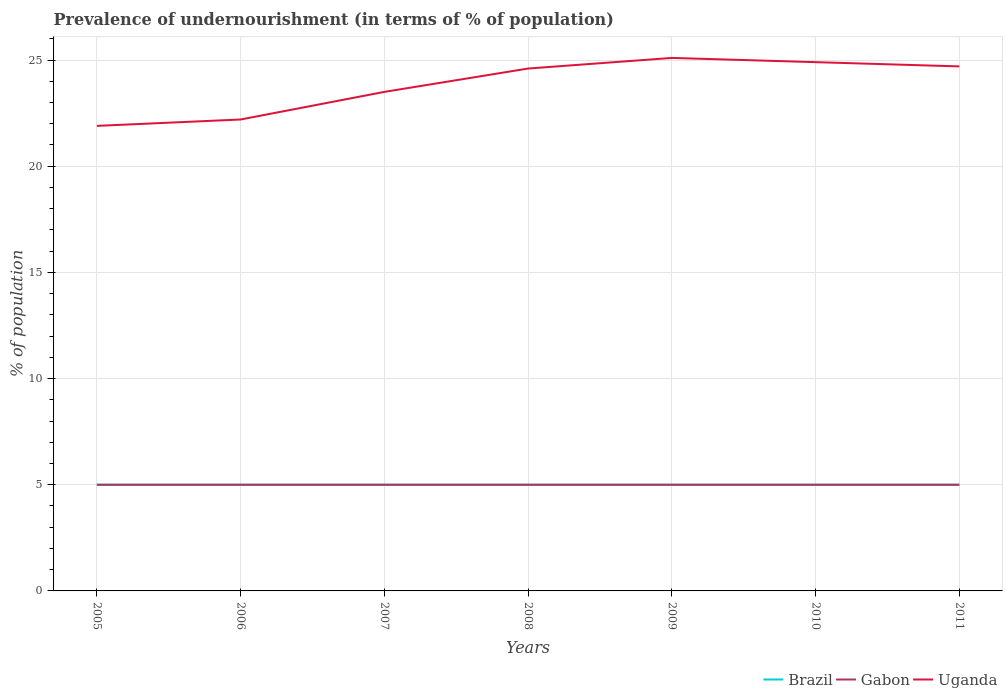Across all years, what is the maximum percentage of undernourished population in Uganda?
Make the answer very short. 21.9. What is the difference between the highest and the lowest percentage of undernourished population in Brazil?
Ensure brevity in your answer.  0. How many lines are there?
Your answer should be very brief. 3. How many years are there in the graph?
Provide a succinct answer. 7. What is the difference between two consecutive major ticks on the Y-axis?
Ensure brevity in your answer.  5. Does the graph contain any zero values?
Provide a succinct answer. No. Where does the legend appear in the graph?
Provide a succinct answer. Bottom right. What is the title of the graph?
Your answer should be very brief. Prevalence of undernourishment (in terms of % of population). What is the label or title of the X-axis?
Provide a short and direct response. Years. What is the label or title of the Y-axis?
Your answer should be very brief. % of population. What is the % of population of Brazil in 2005?
Provide a succinct answer. 5. What is the % of population of Uganda in 2005?
Your response must be concise. 21.9. What is the % of population of Brazil in 2006?
Offer a very short reply. 5. What is the % of population of Gabon in 2006?
Offer a terse response. 5. What is the % of population in Uganda in 2006?
Keep it short and to the point. 22.2. What is the % of population of Brazil in 2007?
Offer a very short reply. 5. What is the % of population of Gabon in 2007?
Offer a terse response. 5. What is the % of population in Gabon in 2008?
Your answer should be very brief. 5. What is the % of population in Uganda in 2008?
Make the answer very short. 24.6. What is the % of population of Gabon in 2009?
Keep it short and to the point. 5. What is the % of population of Uganda in 2009?
Make the answer very short. 25.1. What is the % of population in Uganda in 2010?
Your response must be concise. 24.9. What is the % of population of Brazil in 2011?
Your answer should be very brief. 5. What is the % of population of Gabon in 2011?
Offer a terse response. 5. What is the % of population of Uganda in 2011?
Give a very brief answer. 24.7. Across all years, what is the maximum % of population of Uganda?
Offer a very short reply. 25.1. Across all years, what is the minimum % of population in Uganda?
Keep it short and to the point. 21.9. What is the total % of population in Brazil in the graph?
Your answer should be very brief. 35. What is the total % of population in Gabon in the graph?
Your answer should be very brief. 35. What is the total % of population of Uganda in the graph?
Offer a very short reply. 166.9. What is the difference between the % of population of Gabon in 2005 and that in 2006?
Your response must be concise. 0. What is the difference between the % of population of Uganda in 2005 and that in 2006?
Your answer should be very brief. -0.3. What is the difference between the % of population of Brazil in 2005 and that in 2007?
Give a very brief answer. 0. What is the difference between the % of population of Brazil in 2005 and that in 2009?
Keep it short and to the point. 0. What is the difference between the % of population in Gabon in 2005 and that in 2009?
Offer a very short reply. 0. What is the difference between the % of population in Uganda in 2005 and that in 2010?
Offer a terse response. -3. What is the difference between the % of population in Brazil in 2005 and that in 2011?
Offer a very short reply. 0. What is the difference between the % of population in Gabon in 2005 and that in 2011?
Ensure brevity in your answer.  0. What is the difference between the % of population of Brazil in 2006 and that in 2007?
Keep it short and to the point. 0. What is the difference between the % of population in Gabon in 2006 and that in 2007?
Ensure brevity in your answer.  0. What is the difference between the % of population in Uganda in 2006 and that in 2007?
Provide a short and direct response. -1.3. What is the difference between the % of population of Gabon in 2006 and that in 2008?
Your answer should be very brief. 0. What is the difference between the % of population in Uganda in 2006 and that in 2008?
Your answer should be compact. -2.4. What is the difference between the % of population in Brazil in 2006 and that in 2011?
Your answer should be very brief. 0. What is the difference between the % of population of Gabon in 2006 and that in 2011?
Offer a very short reply. 0. What is the difference between the % of population of Uganda in 2007 and that in 2008?
Provide a short and direct response. -1.1. What is the difference between the % of population of Uganda in 2007 and that in 2009?
Your response must be concise. -1.6. What is the difference between the % of population of Brazil in 2007 and that in 2010?
Offer a very short reply. 0. What is the difference between the % of population in Gabon in 2007 and that in 2011?
Keep it short and to the point. 0. What is the difference between the % of population of Uganda in 2007 and that in 2011?
Provide a short and direct response. -1.2. What is the difference between the % of population in Brazil in 2008 and that in 2009?
Give a very brief answer. 0. What is the difference between the % of population in Uganda in 2008 and that in 2009?
Offer a terse response. -0.5. What is the difference between the % of population of Brazil in 2008 and that in 2010?
Provide a short and direct response. 0. What is the difference between the % of population in Gabon in 2008 and that in 2010?
Make the answer very short. 0. What is the difference between the % of population of Brazil in 2008 and that in 2011?
Offer a terse response. 0. What is the difference between the % of population in Gabon in 2008 and that in 2011?
Your answer should be very brief. 0. What is the difference between the % of population of Brazil in 2009 and that in 2010?
Offer a very short reply. 0. What is the difference between the % of population in Gabon in 2009 and that in 2011?
Provide a short and direct response. 0. What is the difference between the % of population in Brazil in 2010 and that in 2011?
Offer a very short reply. 0. What is the difference between the % of population of Uganda in 2010 and that in 2011?
Keep it short and to the point. 0.2. What is the difference between the % of population of Brazil in 2005 and the % of population of Gabon in 2006?
Provide a succinct answer. 0. What is the difference between the % of population of Brazil in 2005 and the % of population of Uganda in 2006?
Your response must be concise. -17.2. What is the difference between the % of population of Gabon in 2005 and the % of population of Uganda in 2006?
Provide a short and direct response. -17.2. What is the difference between the % of population of Brazil in 2005 and the % of population of Gabon in 2007?
Keep it short and to the point. 0. What is the difference between the % of population of Brazil in 2005 and the % of population of Uganda in 2007?
Your answer should be very brief. -18.5. What is the difference between the % of population of Gabon in 2005 and the % of population of Uganda in 2007?
Your response must be concise. -18.5. What is the difference between the % of population in Brazil in 2005 and the % of population in Gabon in 2008?
Offer a very short reply. 0. What is the difference between the % of population of Brazil in 2005 and the % of population of Uganda in 2008?
Offer a terse response. -19.6. What is the difference between the % of population of Gabon in 2005 and the % of population of Uganda in 2008?
Your answer should be very brief. -19.6. What is the difference between the % of population of Brazil in 2005 and the % of population of Gabon in 2009?
Make the answer very short. 0. What is the difference between the % of population of Brazil in 2005 and the % of population of Uganda in 2009?
Offer a very short reply. -20.1. What is the difference between the % of population in Gabon in 2005 and the % of population in Uganda in 2009?
Provide a short and direct response. -20.1. What is the difference between the % of population in Brazil in 2005 and the % of population in Uganda in 2010?
Keep it short and to the point. -19.9. What is the difference between the % of population of Gabon in 2005 and the % of population of Uganda in 2010?
Make the answer very short. -19.9. What is the difference between the % of population of Brazil in 2005 and the % of population of Uganda in 2011?
Your response must be concise. -19.7. What is the difference between the % of population in Gabon in 2005 and the % of population in Uganda in 2011?
Keep it short and to the point. -19.7. What is the difference between the % of population in Brazil in 2006 and the % of population in Uganda in 2007?
Make the answer very short. -18.5. What is the difference between the % of population in Gabon in 2006 and the % of population in Uganda in 2007?
Ensure brevity in your answer.  -18.5. What is the difference between the % of population in Brazil in 2006 and the % of population in Uganda in 2008?
Make the answer very short. -19.6. What is the difference between the % of population of Gabon in 2006 and the % of population of Uganda in 2008?
Provide a short and direct response. -19.6. What is the difference between the % of population of Brazil in 2006 and the % of population of Gabon in 2009?
Make the answer very short. 0. What is the difference between the % of population in Brazil in 2006 and the % of population in Uganda in 2009?
Your answer should be very brief. -20.1. What is the difference between the % of population in Gabon in 2006 and the % of population in Uganda in 2009?
Offer a very short reply. -20.1. What is the difference between the % of population in Brazil in 2006 and the % of population in Gabon in 2010?
Provide a succinct answer. 0. What is the difference between the % of population of Brazil in 2006 and the % of population of Uganda in 2010?
Your answer should be compact. -19.9. What is the difference between the % of population of Gabon in 2006 and the % of population of Uganda in 2010?
Your answer should be compact. -19.9. What is the difference between the % of population in Brazil in 2006 and the % of population in Uganda in 2011?
Provide a short and direct response. -19.7. What is the difference between the % of population of Gabon in 2006 and the % of population of Uganda in 2011?
Give a very brief answer. -19.7. What is the difference between the % of population in Brazil in 2007 and the % of population in Uganda in 2008?
Provide a short and direct response. -19.6. What is the difference between the % of population of Gabon in 2007 and the % of population of Uganda in 2008?
Offer a very short reply. -19.6. What is the difference between the % of population of Brazil in 2007 and the % of population of Gabon in 2009?
Your answer should be very brief. 0. What is the difference between the % of population in Brazil in 2007 and the % of population in Uganda in 2009?
Your answer should be very brief. -20.1. What is the difference between the % of population in Gabon in 2007 and the % of population in Uganda in 2009?
Give a very brief answer. -20.1. What is the difference between the % of population of Brazil in 2007 and the % of population of Uganda in 2010?
Ensure brevity in your answer.  -19.9. What is the difference between the % of population of Gabon in 2007 and the % of population of Uganda in 2010?
Your response must be concise. -19.9. What is the difference between the % of population in Brazil in 2007 and the % of population in Gabon in 2011?
Keep it short and to the point. 0. What is the difference between the % of population in Brazil in 2007 and the % of population in Uganda in 2011?
Provide a succinct answer. -19.7. What is the difference between the % of population of Gabon in 2007 and the % of population of Uganda in 2011?
Your response must be concise. -19.7. What is the difference between the % of population of Brazil in 2008 and the % of population of Uganda in 2009?
Provide a short and direct response. -20.1. What is the difference between the % of population of Gabon in 2008 and the % of population of Uganda in 2009?
Your answer should be compact. -20.1. What is the difference between the % of population of Brazil in 2008 and the % of population of Gabon in 2010?
Your response must be concise. 0. What is the difference between the % of population in Brazil in 2008 and the % of population in Uganda in 2010?
Offer a very short reply. -19.9. What is the difference between the % of population of Gabon in 2008 and the % of population of Uganda in 2010?
Provide a succinct answer. -19.9. What is the difference between the % of population of Brazil in 2008 and the % of population of Uganda in 2011?
Your answer should be very brief. -19.7. What is the difference between the % of population of Gabon in 2008 and the % of population of Uganda in 2011?
Keep it short and to the point. -19.7. What is the difference between the % of population in Brazil in 2009 and the % of population in Uganda in 2010?
Give a very brief answer. -19.9. What is the difference between the % of population in Gabon in 2009 and the % of population in Uganda in 2010?
Your answer should be compact. -19.9. What is the difference between the % of population in Brazil in 2009 and the % of population in Uganda in 2011?
Your answer should be very brief. -19.7. What is the difference between the % of population of Gabon in 2009 and the % of population of Uganda in 2011?
Your response must be concise. -19.7. What is the difference between the % of population in Brazil in 2010 and the % of population in Uganda in 2011?
Give a very brief answer. -19.7. What is the difference between the % of population of Gabon in 2010 and the % of population of Uganda in 2011?
Keep it short and to the point. -19.7. What is the average % of population of Brazil per year?
Offer a very short reply. 5. What is the average % of population of Gabon per year?
Offer a terse response. 5. What is the average % of population of Uganda per year?
Provide a short and direct response. 23.84. In the year 2005, what is the difference between the % of population of Brazil and % of population of Gabon?
Provide a short and direct response. 0. In the year 2005, what is the difference between the % of population of Brazil and % of population of Uganda?
Ensure brevity in your answer.  -16.9. In the year 2005, what is the difference between the % of population of Gabon and % of population of Uganda?
Make the answer very short. -16.9. In the year 2006, what is the difference between the % of population of Brazil and % of population of Uganda?
Give a very brief answer. -17.2. In the year 2006, what is the difference between the % of population of Gabon and % of population of Uganda?
Provide a short and direct response. -17.2. In the year 2007, what is the difference between the % of population in Brazil and % of population in Gabon?
Give a very brief answer. 0. In the year 2007, what is the difference between the % of population in Brazil and % of population in Uganda?
Offer a very short reply. -18.5. In the year 2007, what is the difference between the % of population in Gabon and % of population in Uganda?
Ensure brevity in your answer.  -18.5. In the year 2008, what is the difference between the % of population in Brazil and % of population in Gabon?
Your response must be concise. 0. In the year 2008, what is the difference between the % of population of Brazil and % of population of Uganda?
Make the answer very short. -19.6. In the year 2008, what is the difference between the % of population in Gabon and % of population in Uganda?
Provide a short and direct response. -19.6. In the year 2009, what is the difference between the % of population in Brazil and % of population in Uganda?
Make the answer very short. -20.1. In the year 2009, what is the difference between the % of population of Gabon and % of population of Uganda?
Keep it short and to the point. -20.1. In the year 2010, what is the difference between the % of population in Brazil and % of population in Gabon?
Your answer should be very brief. 0. In the year 2010, what is the difference between the % of population in Brazil and % of population in Uganda?
Ensure brevity in your answer.  -19.9. In the year 2010, what is the difference between the % of population in Gabon and % of population in Uganda?
Your response must be concise. -19.9. In the year 2011, what is the difference between the % of population in Brazil and % of population in Uganda?
Provide a short and direct response. -19.7. In the year 2011, what is the difference between the % of population of Gabon and % of population of Uganda?
Offer a very short reply. -19.7. What is the ratio of the % of population in Gabon in 2005 to that in 2006?
Offer a terse response. 1. What is the ratio of the % of population in Uganda in 2005 to that in 2006?
Offer a very short reply. 0.99. What is the ratio of the % of population of Brazil in 2005 to that in 2007?
Offer a terse response. 1. What is the ratio of the % of population of Gabon in 2005 to that in 2007?
Offer a terse response. 1. What is the ratio of the % of population in Uganda in 2005 to that in 2007?
Your answer should be compact. 0.93. What is the ratio of the % of population in Brazil in 2005 to that in 2008?
Offer a very short reply. 1. What is the ratio of the % of population of Gabon in 2005 to that in 2008?
Your response must be concise. 1. What is the ratio of the % of population in Uganda in 2005 to that in 2008?
Offer a very short reply. 0.89. What is the ratio of the % of population of Brazil in 2005 to that in 2009?
Offer a very short reply. 1. What is the ratio of the % of population in Gabon in 2005 to that in 2009?
Your answer should be compact. 1. What is the ratio of the % of population in Uganda in 2005 to that in 2009?
Keep it short and to the point. 0.87. What is the ratio of the % of population of Brazil in 2005 to that in 2010?
Your answer should be very brief. 1. What is the ratio of the % of population of Uganda in 2005 to that in 2010?
Offer a very short reply. 0.88. What is the ratio of the % of population of Brazil in 2005 to that in 2011?
Offer a terse response. 1. What is the ratio of the % of population in Gabon in 2005 to that in 2011?
Provide a short and direct response. 1. What is the ratio of the % of population in Uganda in 2005 to that in 2011?
Your response must be concise. 0.89. What is the ratio of the % of population in Uganda in 2006 to that in 2007?
Your answer should be compact. 0.94. What is the ratio of the % of population of Brazil in 2006 to that in 2008?
Make the answer very short. 1. What is the ratio of the % of population of Uganda in 2006 to that in 2008?
Provide a succinct answer. 0.9. What is the ratio of the % of population of Uganda in 2006 to that in 2009?
Ensure brevity in your answer.  0.88. What is the ratio of the % of population of Gabon in 2006 to that in 2010?
Your answer should be very brief. 1. What is the ratio of the % of population in Uganda in 2006 to that in 2010?
Your response must be concise. 0.89. What is the ratio of the % of population in Gabon in 2006 to that in 2011?
Your answer should be compact. 1. What is the ratio of the % of population in Uganda in 2006 to that in 2011?
Provide a succinct answer. 0.9. What is the ratio of the % of population of Brazil in 2007 to that in 2008?
Your answer should be compact. 1. What is the ratio of the % of population of Uganda in 2007 to that in 2008?
Provide a short and direct response. 0.96. What is the ratio of the % of population of Gabon in 2007 to that in 2009?
Offer a very short reply. 1. What is the ratio of the % of population in Uganda in 2007 to that in 2009?
Offer a very short reply. 0.94. What is the ratio of the % of population of Brazil in 2007 to that in 2010?
Keep it short and to the point. 1. What is the ratio of the % of population of Gabon in 2007 to that in 2010?
Offer a terse response. 1. What is the ratio of the % of population of Uganda in 2007 to that in 2010?
Make the answer very short. 0.94. What is the ratio of the % of population of Uganda in 2007 to that in 2011?
Give a very brief answer. 0.95. What is the ratio of the % of population in Gabon in 2008 to that in 2009?
Provide a succinct answer. 1. What is the ratio of the % of population in Uganda in 2008 to that in 2009?
Make the answer very short. 0.98. What is the ratio of the % of population in Brazil in 2008 to that in 2010?
Make the answer very short. 1. What is the ratio of the % of population in Uganda in 2008 to that in 2010?
Provide a succinct answer. 0.99. What is the ratio of the % of population in Brazil in 2008 to that in 2011?
Make the answer very short. 1. What is the ratio of the % of population of Brazil in 2009 to that in 2011?
Make the answer very short. 1. What is the ratio of the % of population of Uganda in 2009 to that in 2011?
Ensure brevity in your answer.  1.02. What is the difference between the highest and the second highest % of population of Uganda?
Make the answer very short. 0.2. What is the difference between the highest and the lowest % of population of Brazil?
Provide a short and direct response. 0. 